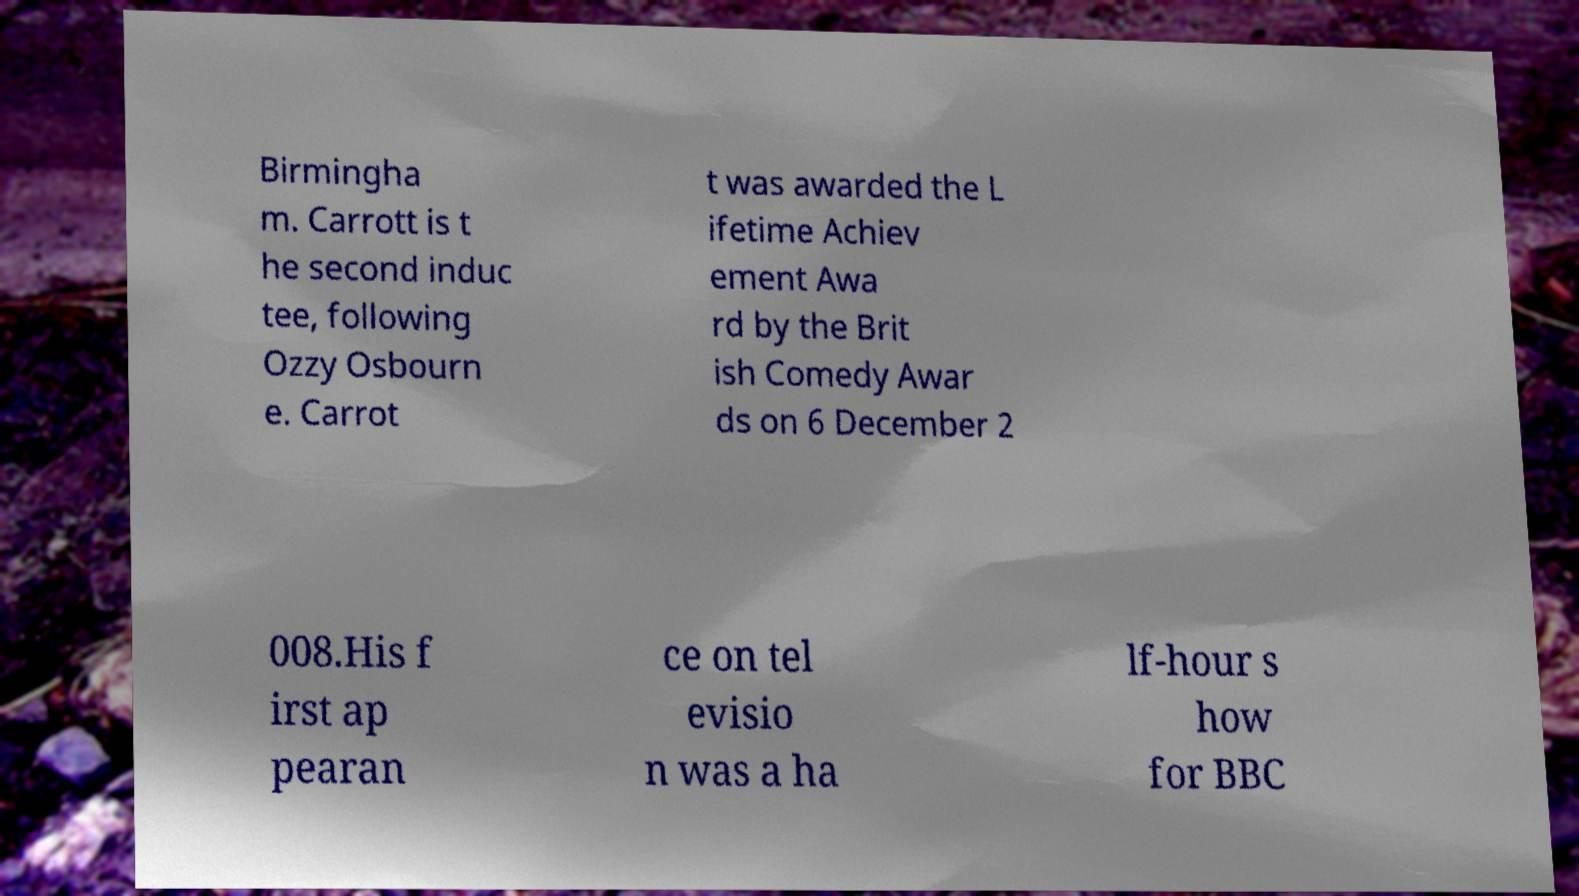What messages or text are displayed in this image? I need them in a readable, typed format. Birmingha m. Carrott is t he second induc tee, following Ozzy Osbourn e. Carrot t was awarded the L ifetime Achiev ement Awa rd by the Brit ish Comedy Awar ds on 6 December 2 008.His f irst ap pearan ce on tel evisio n was a ha lf-hour s how for BBC 